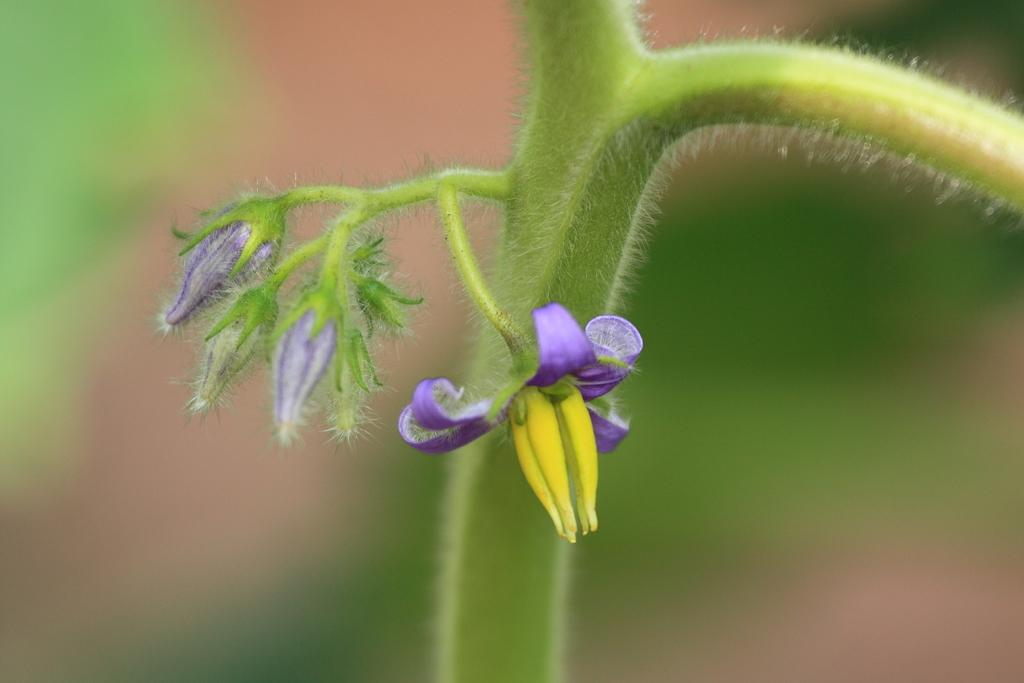What is the main subject of the image? The main subject of the image is a group of flowers. Where are the flowers located in the image? The flowers are on the stem of a plant. What type of expansion can be seen in the image? There is no expansion visible in the image; it features a group of flowers on the stem of a plant. Can you describe the pear that is present in the image? There is no pear present in the image. 